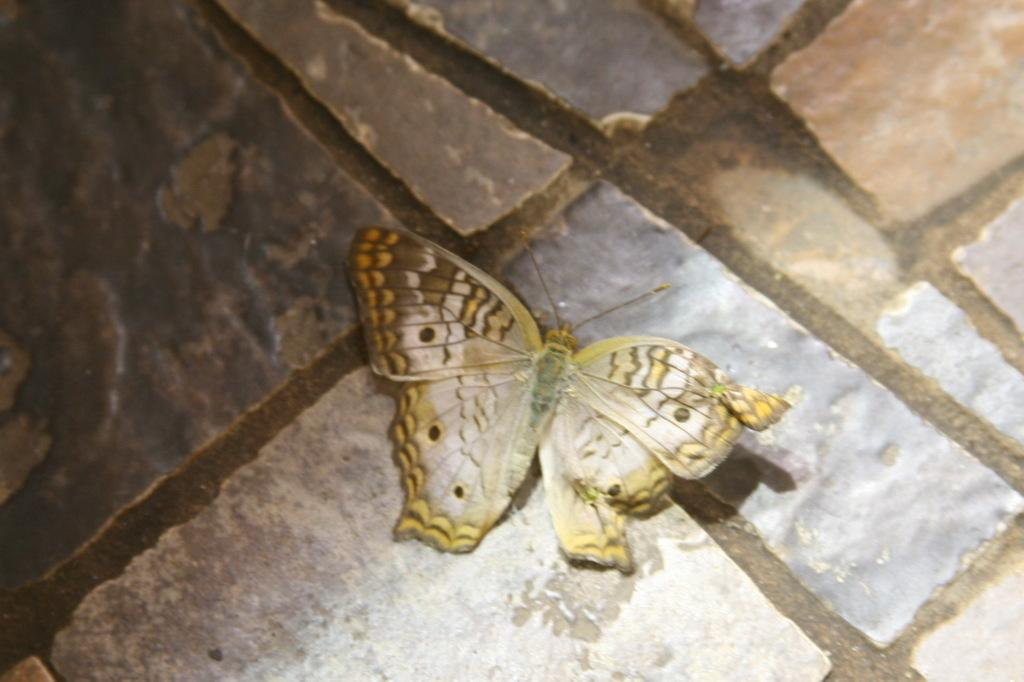What type of animal can be seen in the picture? There is a butterfly in the picture. What natural elements are present in the picture? There are rocks in the picture. What type of corn is being prepared by the maid in the picture? There is no maid or corn present in the picture; it only features a butterfly and rocks. 